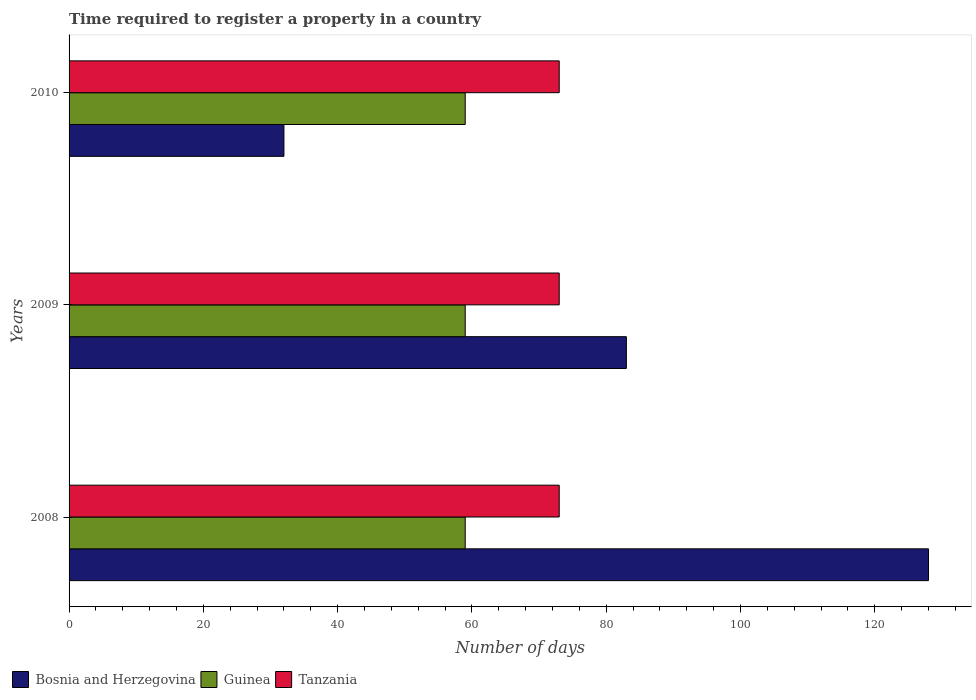How many different coloured bars are there?
Give a very brief answer. 3. Are the number of bars on each tick of the Y-axis equal?
Your response must be concise. Yes. How many bars are there on the 2nd tick from the top?
Keep it short and to the point. 3. How many bars are there on the 1st tick from the bottom?
Your response must be concise. 3. What is the label of the 3rd group of bars from the top?
Offer a very short reply. 2008. What is the number of days required to register a property in Bosnia and Herzegovina in 2008?
Your answer should be compact. 128. Across all years, what is the maximum number of days required to register a property in Tanzania?
Offer a terse response. 73. Across all years, what is the minimum number of days required to register a property in Bosnia and Herzegovina?
Your answer should be compact. 32. In which year was the number of days required to register a property in Tanzania minimum?
Ensure brevity in your answer.  2008. What is the total number of days required to register a property in Bosnia and Herzegovina in the graph?
Your answer should be compact. 243. What is the difference between the number of days required to register a property in Bosnia and Herzegovina in 2009 and that in 2010?
Offer a terse response. 51. What is the difference between the number of days required to register a property in Tanzania in 2010 and the number of days required to register a property in Guinea in 2009?
Offer a terse response. 14. What is the average number of days required to register a property in Bosnia and Herzegovina per year?
Provide a succinct answer. 81. In the year 2009, what is the difference between the number of days required to register a property in Tanzania and number of days required to register a property in Bosnia and Herzegovina?
Make the answer very short. -10. What is the ratio of the number of days required to register a property in Tanzania in 2008 to that in 2010?
Your response must be concise. 1. Is the difference between the number of days required to register a property in Tanzania in 2008 and 2010 greater than the difference between the number of days required to register a property in Bosnia and Herzegovina in 2008 and 2010?
Provide a short and direct response. No. What is the difference between the highest and the lowest number of days required to register a property in Bosnia and Herzegovina?
Offer a terse response. 96. Is the sum of the number of days required to register a property in Guinea in 2008 and 2009 greater than the maximum number of days required to register a property in Tanzania across all years?
Keep it short and to the point. Yes. What does the 1st bar from the top in 2009 represents?
Your answer should be very brief. Tanzania. What does the 3rd bar from the bottom in 2008 represents?
Your answer should be compact. Tanzania. How many bars are there?
Your response must be concise. 9. Are all the bars in the graph horizontal?
Offer a terse response. Yes. Are the values on the major ticks of X-axis written in scientific E-notation?
Your answer should be compact. No. Where does the legend appear in the graph?
Give a very brief answer. Bottom left. How many legend labels are there?
Offer a very short reply. 3. How are the legend labels stacked?
Provide a short and direct response. Horizontal. What is the title of the graph?
Give a very brief answer. Time required to register a property in a country. Does "Sub-Saharan Africa (all income levels)" appear as one of the legend labels in the graph?
Give a very brief answer. No. What is the label or title of the X-axis?
Offer a very short reply. Number of days. What is the Number of days in Bosnia and Herzegovina in 2008?
Your response must be concise. 128. What is the Number of days in Guinea in 2008?
Your answer should be very brief. 59. What is the Number of days in Tanzania in 2008?
Give a very brief answer. 73. What is the Number of days of Bosnia and Herzegovina in 2009?
Offer a very short reply. 83. What is the Number of days in Guinea in 2009?
Give a very brief answer. 59. What is the Number of days in Tanzania in 2009?
Give a very brief answer. 73. What is the Number of days in Bosnia and Herzegovina in 2010?
Your answer should be compact. 32. What is the Number of days in Tanzania in 2010?
Your answer should be very brief. 73. Across all years, what is the maximum Number of days in Bosnia and Herzegovina?
Ensure brevity in your answer.  128. Across all years, what is the maximum Number of days of Guinea?
Your answer should be very brief. 59. Across all years, what is the maximum Number of days of Tanzania?
Your answer should be compact. 73. What is the total Number of days of Bosnia and Herzegovina in the graph?
Give a very brief answer. 243. What is the total Number of days of Guinea in the graph?
Ensure brevity in your answer.  177. What is the total Number of days of Tanzania in the graph?
Offer a very short reply. 219. What is the difference between the Number of days of Tanzania in 2008 and that in 2009?
Ensure brevity in your answer.  0. What is the difference between the Number of days of Bosnia and Herzegovina in 2008 and that in 2010?
Offer a very short reply. 96. What is the difference between the Number of days of Guinea in 2008 and that in 2010?
Keep it short and to the point. 0. What is the difference between the Number of days of Bosnia and Herzegovina in 2009 and that in 2010?
Provide a short and direct response. 51. What is the difference between the Number of days of Guinea in 2009 and that in 2010?
Offer a very short reply. 0. What is the difference between the Number of days in Bosnia and Herzegovina in 2008 and the Number of days in Tanzania in 2009?
Offer a very short reply. 55. What is the difference between the Number of days of Bosnia and Herzegovina in 2008 and the Number of days of Tanzania in 2010?
Your answer should be very brief. 55. What is the difference between the Number of days of Guinea in 2008 and the Number of days of Tanzania in 2010?
Offer a very short reply. -14. What is the difference between the Number of days of Bosnia and Herzegovina in 2009 and the Number of days of Guinea in 2010?
Offer a terse response. 24. What is the difference between the Number of days in Guinea in 2009 and the Number of days in Tanzania in 2010?
Your answer should be compact. -14. What is the average Number of days in Tanzania per year?
Ensure brevity in your answer.  73. In the year 2008, what is the difference between the Number of days in Bosnia and Herzegovina and Number of days in Guinea?
Your answer should be very brief. 69. In the year 2009, what is the difference between the Number of days in Guinea and Number of days in Tanzania?
Keep it short and to the point. -14. In the year 2010, what is the difference between the Number of days of Bosnia and Herzegovina and Number of days of Tanzania?
Provide a succinct answer. -41. What is the ratio of the Number of days in Bosnia and Herzegovina in 2008 to that in 2009?
Offer a very short reply. 1.54. What is the ratio of the Number of days of Tanzania in 2008 to that in 2009?
Your answer should be very brief. 1. What is the ratio of the Number of days of Bosnia and Herzegovina in 2009 to that in 2010?
Keep it short and to the point. 2.59. What is the ratio of the Number of days of Guinea in 2009 to that in 2010?
Your answer should be very brief. 1. What is the ratio of the Number of days of Tanzania in 2009 to that in 2010?
Offer a very short reply. 1. What is the difference between the highest and the second highest Number of days in Bosnia and Herzegovina?
Provide a succinct answer. 45. What is the difference between the highest and the second highest Number of days of Tanzania?
Keep it short and to the point. 0. What is the difference between the highest and the lowest Number of days in Bosnia and Herzegovina?
Offer a very short reply. 96. What is the difference between the highest and the lowest Number of days in Tanzania?
Your answer should be very brief. 0. 